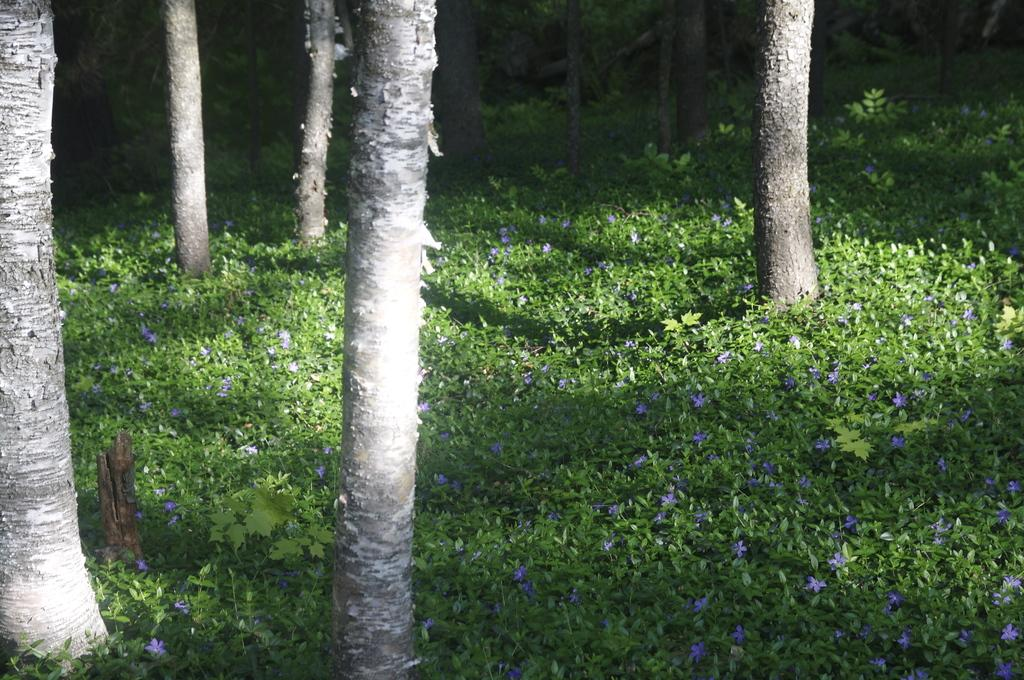What type of natural objects can be seen in the image? There are many trunks of trees and plants in the image. What additional features can be observed on the plants? There are flowers on the plants in the image. What type of scent can be detected from the leather in the image? There is no leather present in the image, so it is not possible to detect any scent. 